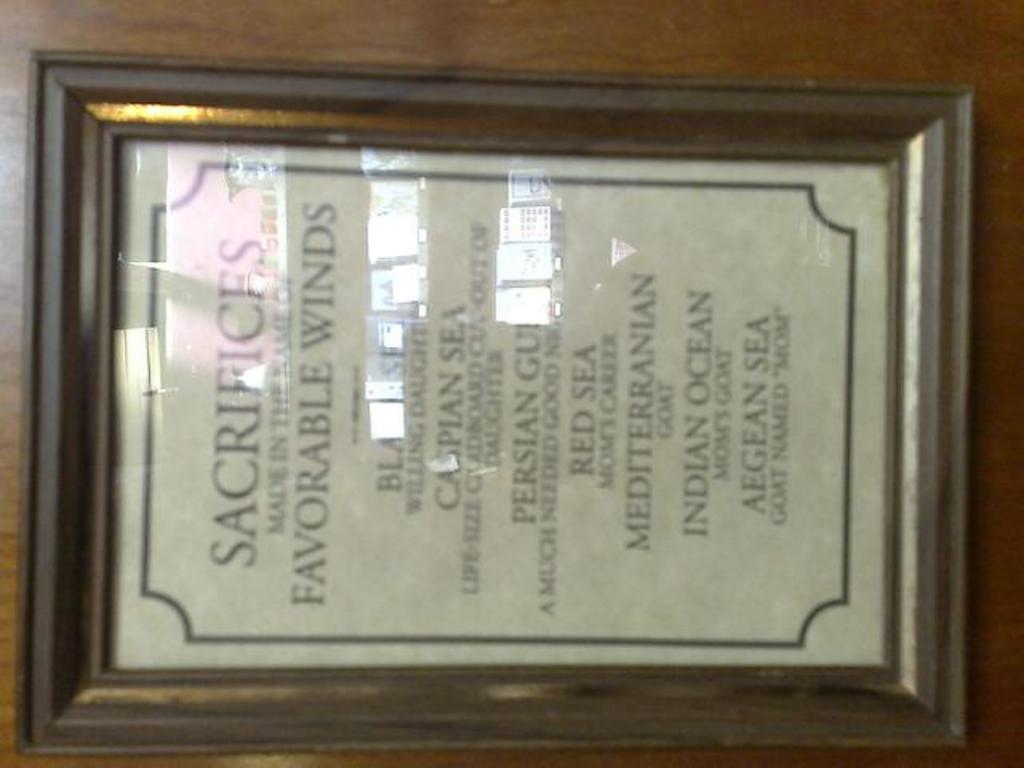What kind of winds are shown?
Keep it short and to the point. Favorable. Is this a copy of sacrifices made by sailors?
Provide a succinct answer. Yes. 